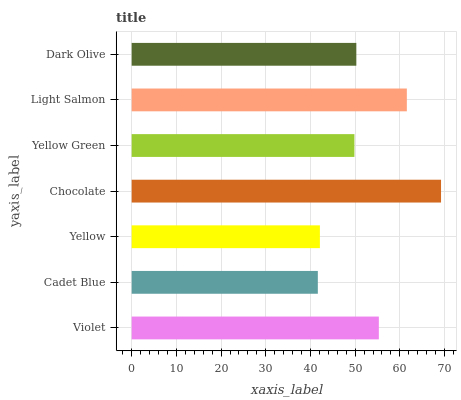Is Cadet Blue the minimum?
Answer yes or no. Yes. Is Chocolate the maximum?
Answer yes or no. Yes. Is Yellow the minimum?
Answer yes or no. No. Is Yellow the maximum?
Answer yes or no. No. Is Yellow greater than Cadet Blue?
Answer yes or no. Yes. Is Cadet Blue less than Yellow?
Answer yes or no. Yes. Is Cadet Blue greater than Yellow?
Answer yes or no. No. Is Yellow less than Cadet Blue?
Answer yes or no. No. Is Dark Olive the high median?
Answer yes or no. Yes. Is Dark Olive the low median?
Answer yes or no. Yes. Is Yellow the high median?
Answer yes or no. No. Is Chocolate the low median?
Answer yes or no. No. 